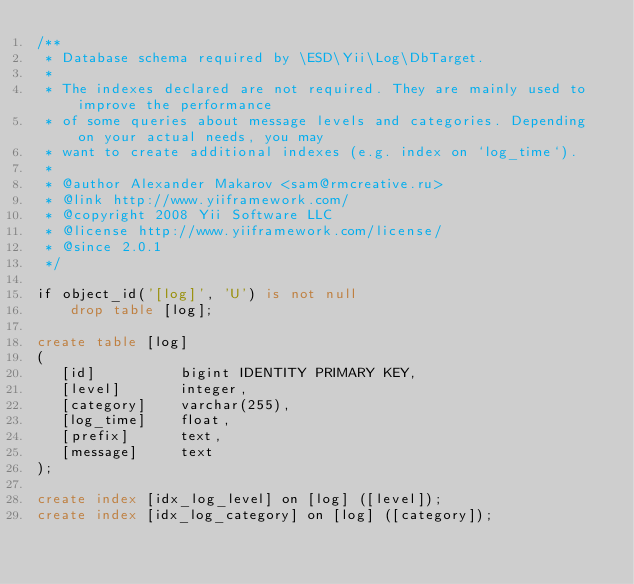Convert code to text. <code><loc_0><loc_0><loc_500><loc_500><_SQL_>/**
 * Database schema required by \ESD\Yii\Log\DbTarget.
 *
 * The indexes declared are not required. They are mainly used to improve the performance
 * of some queries about message levels and categories. Depending on your actual needs, you may
 * want to create additional indexes (e.g. index on `log_time`).
 *
 * @author Alexander Makarov <sam@rmcreative.ru>
 * @link http://www.yiiframework.com/
 * @copyright 2008 Yii Software LLC
 * @license http://www.yiiframework.com/license/
 * @since 2.0.1
 */

if object_id('[log]', 'U') is not null
    drop table [log];

create table [log]
(
   [id]          bigint IDENTITY PRIMARY KEY,
   [level]       integer,
   [category]    varchar(255),
   [log_time]    float,
   [prefix]      text,
   [message]     text
);

create index [idx_log_level] on [log] ([level]);
create index [idx_log_category] on [log] ([category]);
</code> 